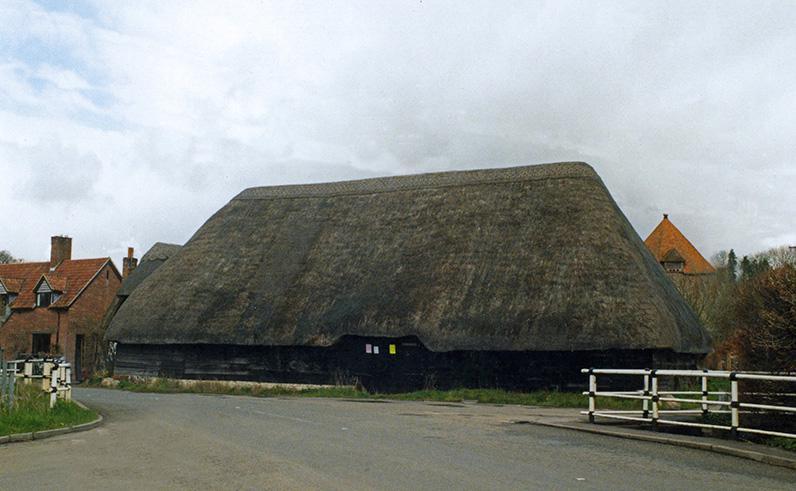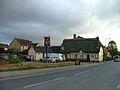The first image is the image on the left, the second image is the image on the right. For the images displayed, is the sentence "People are standing in front of one of the buildings." factually correct? Answer yes or no. No. The first image is the image on the left, the second image is the image on the right. Assess this claim about the two images: "In at least one image, there are at least two homes with white walls.". Correct or not? Answer yes or no. Yes. 